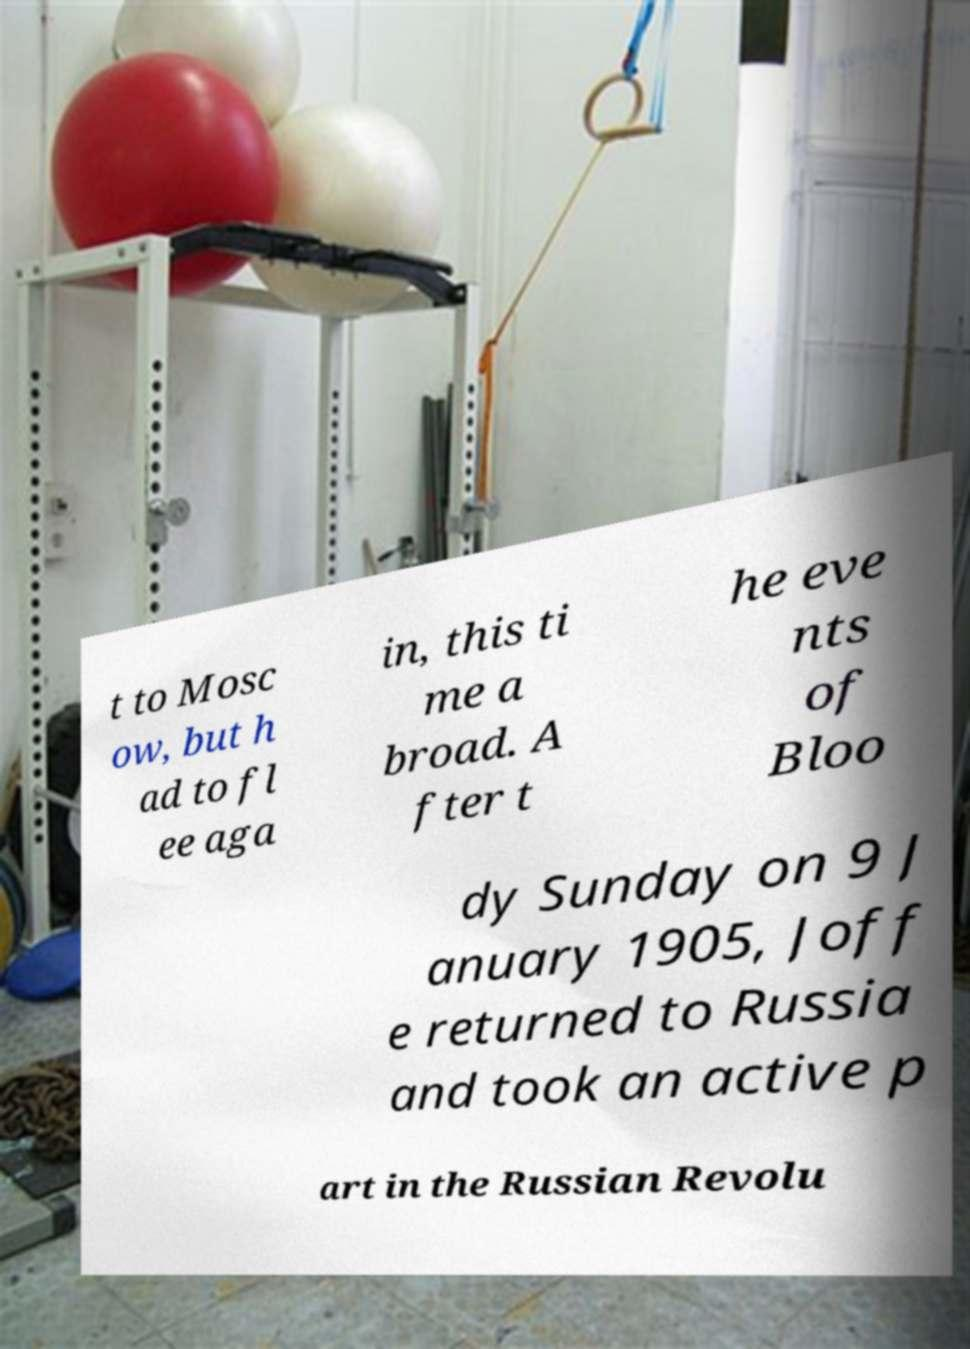Could you assist in decoding the text presented in this image and type it out clearly? t to Mosc ow, but h ad to fl ee aga in, this ti me a broad. A fter t he eve nts of Bloo dy Sunday on 9 J anuary 1905, Joff e returned to Russia and took an active p art in the Russian Revolu 